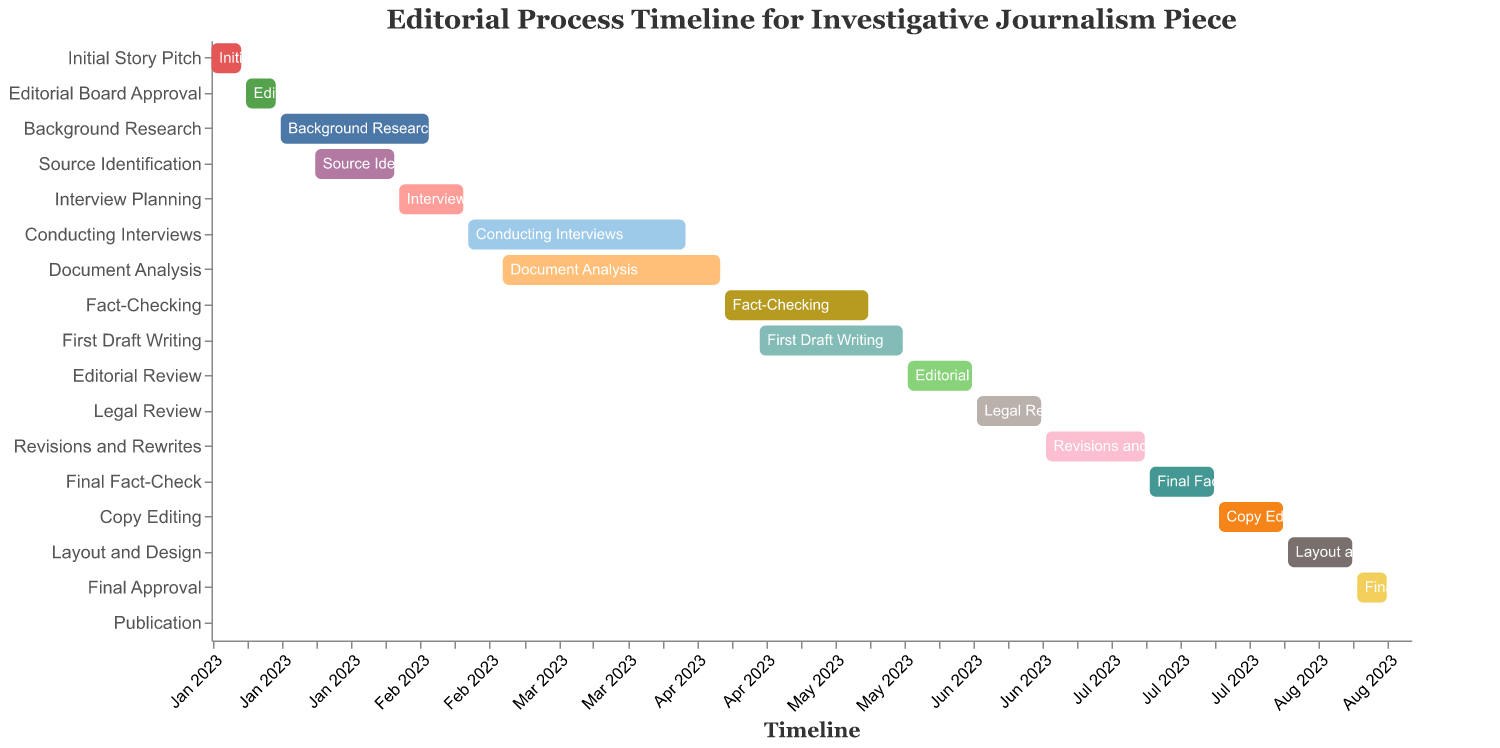What is the title of the Gantt Chart? The title is located at the top of the chart within the "text" label. The title helps provide context about the chart's subject.
Answer: Editorial Process Timeline for Investigative Journalism Piece What is the date range for "Fact-Checking"? Locate the "Fact-Checking" task on the vertical axis (Task), and refer to the horizontal timeline between "Start Date" and "End Date".
Answer: April 15, 2023 - May 14, 2023 Which tasks overlap with "Background Research"? Identify the "Background Research" task on the Gantt Chart and note its duration. Then, look for other tasks that have bars overlapping with this duration.
Answer: Source Identification How long does "Conducting Interviews" last? Find the "Conducting Interviews" task and measure the duration between its "Start Date" and "End Date".
Answer: 46 days Which task ends first: "Background Research" or "Source Identification"? Compare the "End Date" of both "Background Research" and "Source Identification" tasks.
Answer: Source Identification Which tasks take place after "Editorial Review" is completed? Locate the "Editorial Review" task and note its "End Date". Then, identify tasks that have their "Start Date" positioned after this date.
Answer: Legal Review, Revisions and Rewrites, Final Fact-Check, Copy Editing, Layout and Design, Final Approval, Publication During which month does "Final Approval" occur? Find the "Final Approval" task and look at its "Start Date" and "End Date" on the timeline to determine the month.
Answer: August What is the longest task in the editorial process? Compare the durations of all tasks by looking at the time span between "Start Date" and "End Date".
Answer: Conducting Interviews How many tasks are completed by August 2023? Identify tasks that have their "End Date" on or before August 31, 2023.
Answer: 14 tasks What is the relationship between the "Interview Planning" and "Document Analysis" tasks? Find the "Interview Planning" and "Document Analysis" tasks, then compare their durations to see if they overlap or follow each other sequentially.
Answer: Interview Planning precedes Document Analysis 